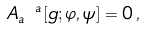Convert formula to latex. <formula><loc_0><loc_0><loc_500><loc_500>A _ { a } ^ { \ a } [ g ; \varphi , \psi ] = 0 \, ,</formula> 